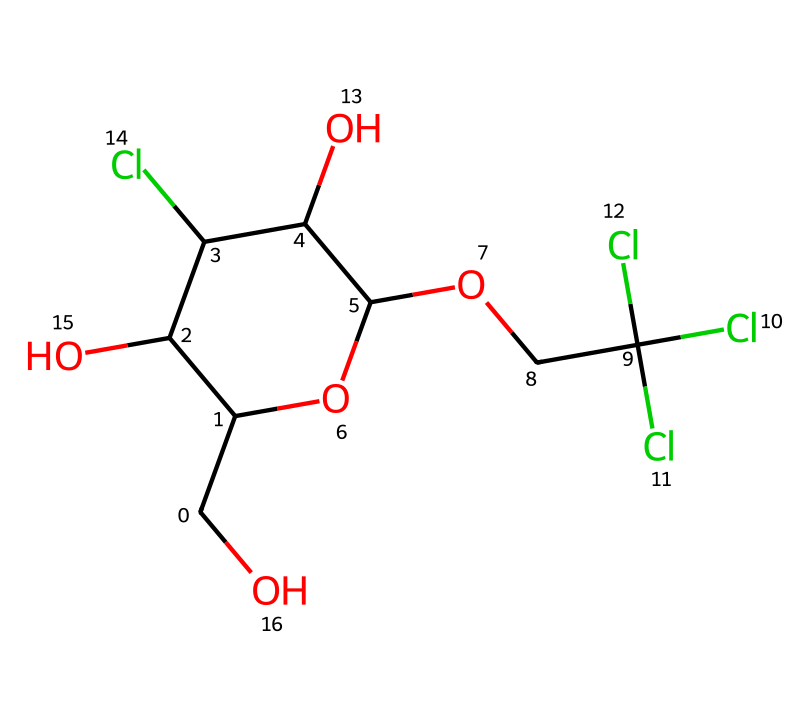What is the molecular formula of sucralose? To find the molecular formula, count the number of each type of atom in the SMILES representation. The counts are 12 Carbon (C), 19 Hydrogen (H), and 6 Chlorine (Cl). Therefore, the molecular formula is C12H19Cl6O8.
Answer: C12H19Cl6O8 How many chlorine atoms are present in sucralose? By analyzing the SMILES notation, we identify that there are three instances of "Cl" which indicates three chlorine atoms in the structure.
Answer: three What is the functional group present in sucralose? In the structure of sucralose, we see multiple hydroxyl (OH) groups. The presence of these hydroxyl groups indicates that the functional group is alcohol.
Answer: alcohol What property does the presence of chlorines contribute to sucralose? The chlorine atoms increase the sweetness by significantly enhancing the compounds' sweet taste while also reducing the caloric value, making it ideal as a sugar substitute.
Answer: enhances sweetness Is sucralose an imide? Sucralose does not have the structure characteristic of imides, which typically include nitrogen atoms and are derived from the reactions of carboxylic acids and amines. Therefore, sucralose does not qualify as an imide.
Answer: no How many hydroxyl (-OH) groups are there in sucralose? The SMILES notation shows the presence of four instances of the -OH group. This can be confirmed by counting the occurrences of "O" followed by a connection to "H". Thus, there are four hydroxyl groups.
Answer: four 